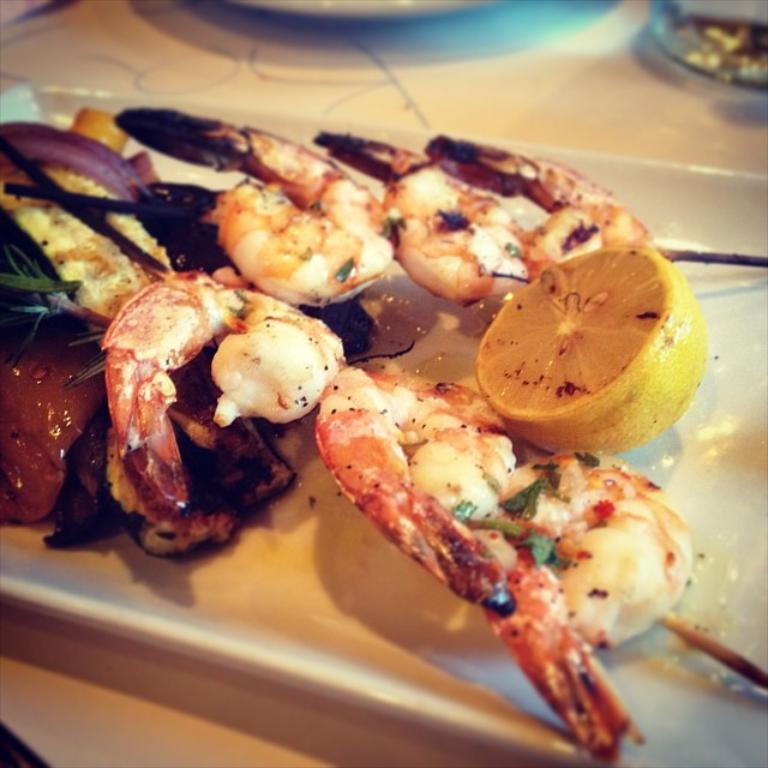What type of seafood is present in the image? There are king prawns in the image. What accompaniment can be seen with the king prawns? There is a slice of lemon in the image. Where is the lemon placed? The lemon is placed on a plate. On what surface is the plate resting? The plate is on top of a table. What type of road can be seen in the image? There is no road present in the image; it features king prawns, a slice of lemon, a plate, and a table. Is there a branch visible in the image? There is no branch present in the image. 